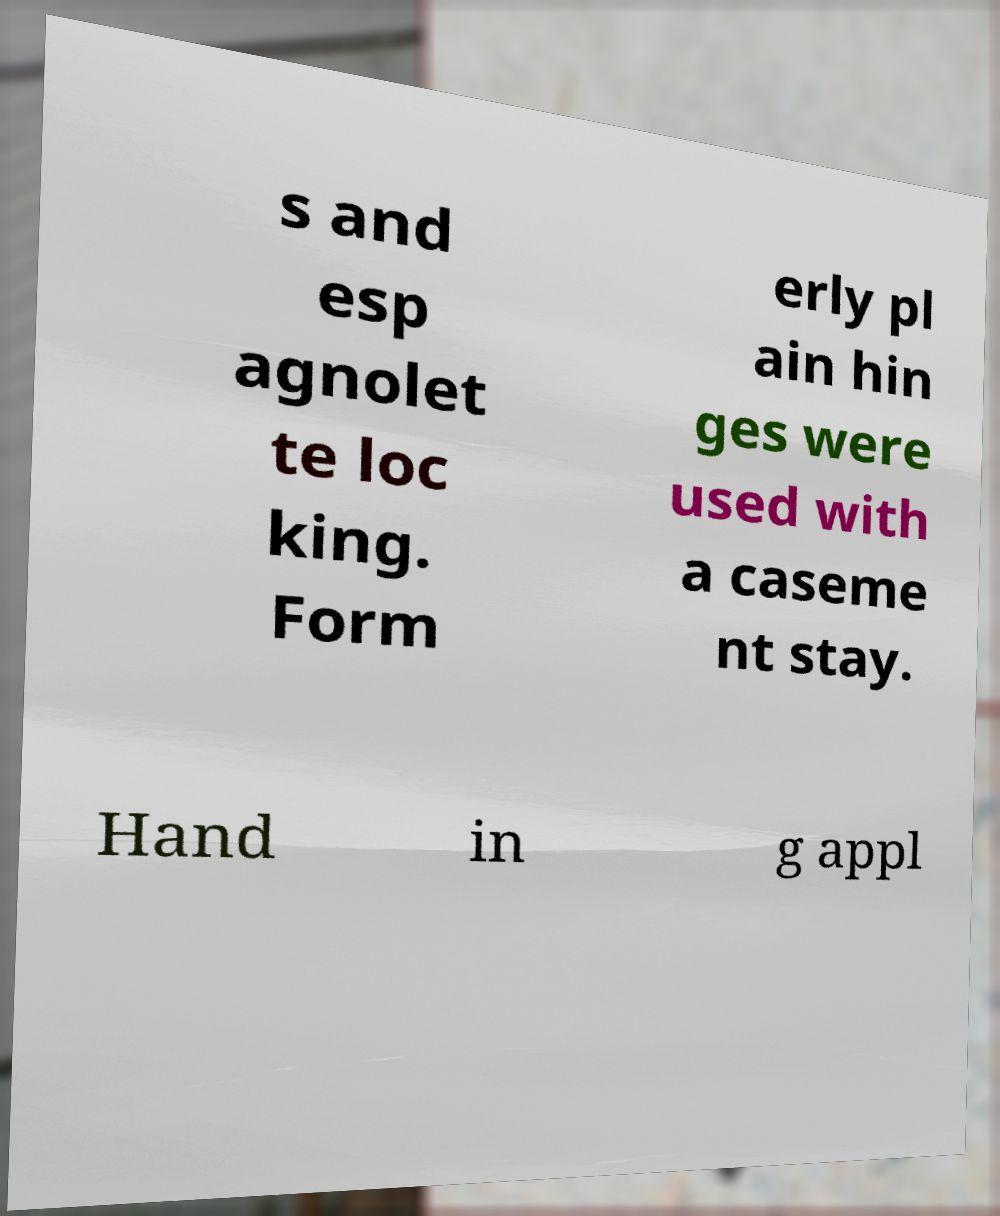Please read and relay the text visible in this image. What does it say? s and esp agnolet te loc king. Form erly pl ain hin ges were used with a caseme nt stay. Hand in g appl 